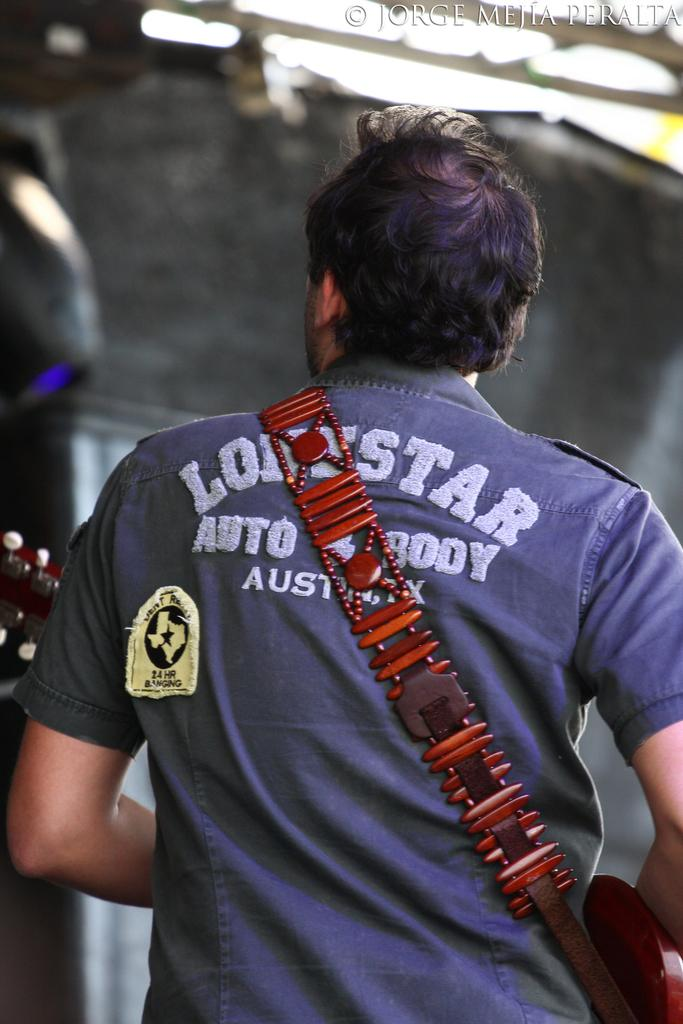<image>
Give a short and clear explanation of the subsequent image. a lonestar shirt on the man with a strap 